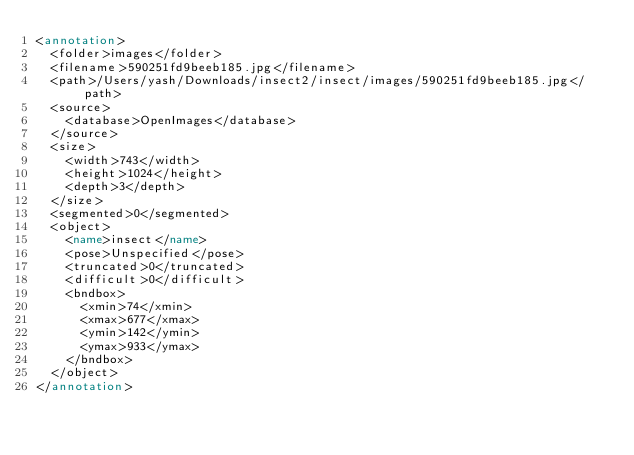Convert code to text. <code><loc_0><loc_0><loc_500><loc_500><_XML_><annotation>
  <folder>images</folder>
  <filename>590251fd9beeb185.jpg</filename>
  <path>/Users/yash/Downloads/insect2/insect/images/590251fd9beeb185.jpg</path>
  <source>
    <database>OpenImages</database>
  </source>
  <size>
    <width>743</width>
    <height>1024</height>
    <depth>3</depth>
  </size>
  <segmented>0</segmented>
  <object>
    <name>insect</name>
    <pose>Unspecified</pose>
    <truncated>0</truncated>
    <difficult>0</difficult>
    <bndbox>
      <xmin>74</xmin>
      <xmax>677</xmax>
      <ymin>142</ymin>
      <ymax>933</ymax>
    </bndbox>
  </object>
</annotation>
</code> 